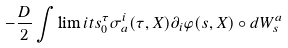<formula> <loc_0><loc_0><loc_500><loc_500>- \frac { D } { 2 } \int \lim i t s _ { 0 } ^ { \tau } \sigma _ { a } ^ { i } ( \tau , X ) \partial _ { i } \varphi ( s , X ) \circ d W _ { s } ^ { a }</formula> 